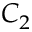Convert formula to latex. <formula><loc_0><loc_0><loc_500><loc_500>C _ { 2 }</formula> 